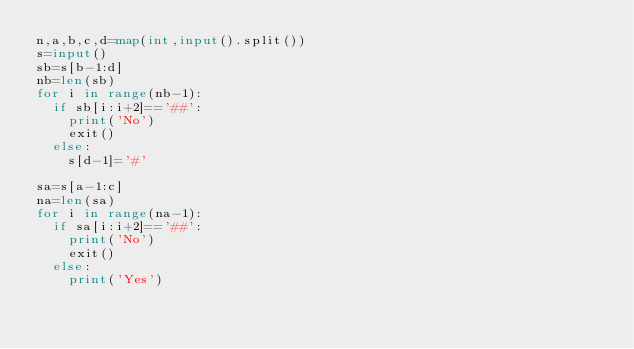Convert code to text. <code><loc_0><loc_0><loc_500><loc_500><_Python_>n,a,b,c,d=map(int,input().split())
s=input()
sb=s[b-1:d]
nb=len(sb)
for i in range(nb-1):
  if sb[i:i+2]=='##':
    print('No')
    exit()
  else:
    s[d-1]='#'
    
sa=s[a-1:c]
na=len(sa)
for i in range(na-1):
  if sa[i:i+2]=='##':
    print('No')
    exit()
  else:
    print('Yes')</code> 